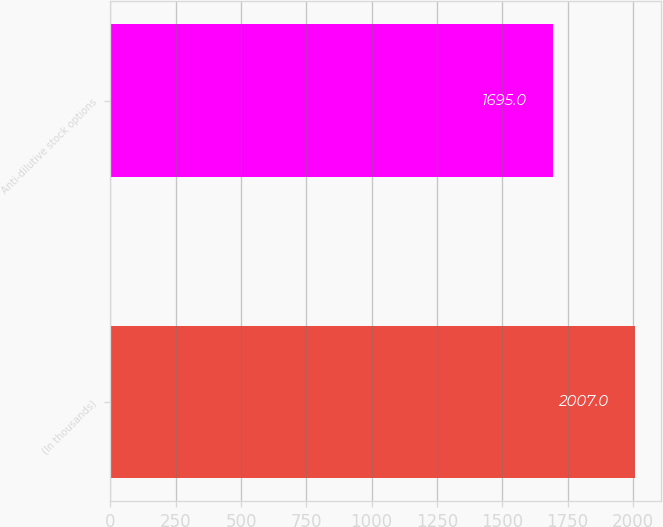Convert chart to OTSL. <chart><loc_0><loc_0><loc_500><loc_500><bar_chart><fcel>(In thousands)<fcel>Anti-dilutive stock options<nl><fcel>2007<fcel>1695<nl></chart> 